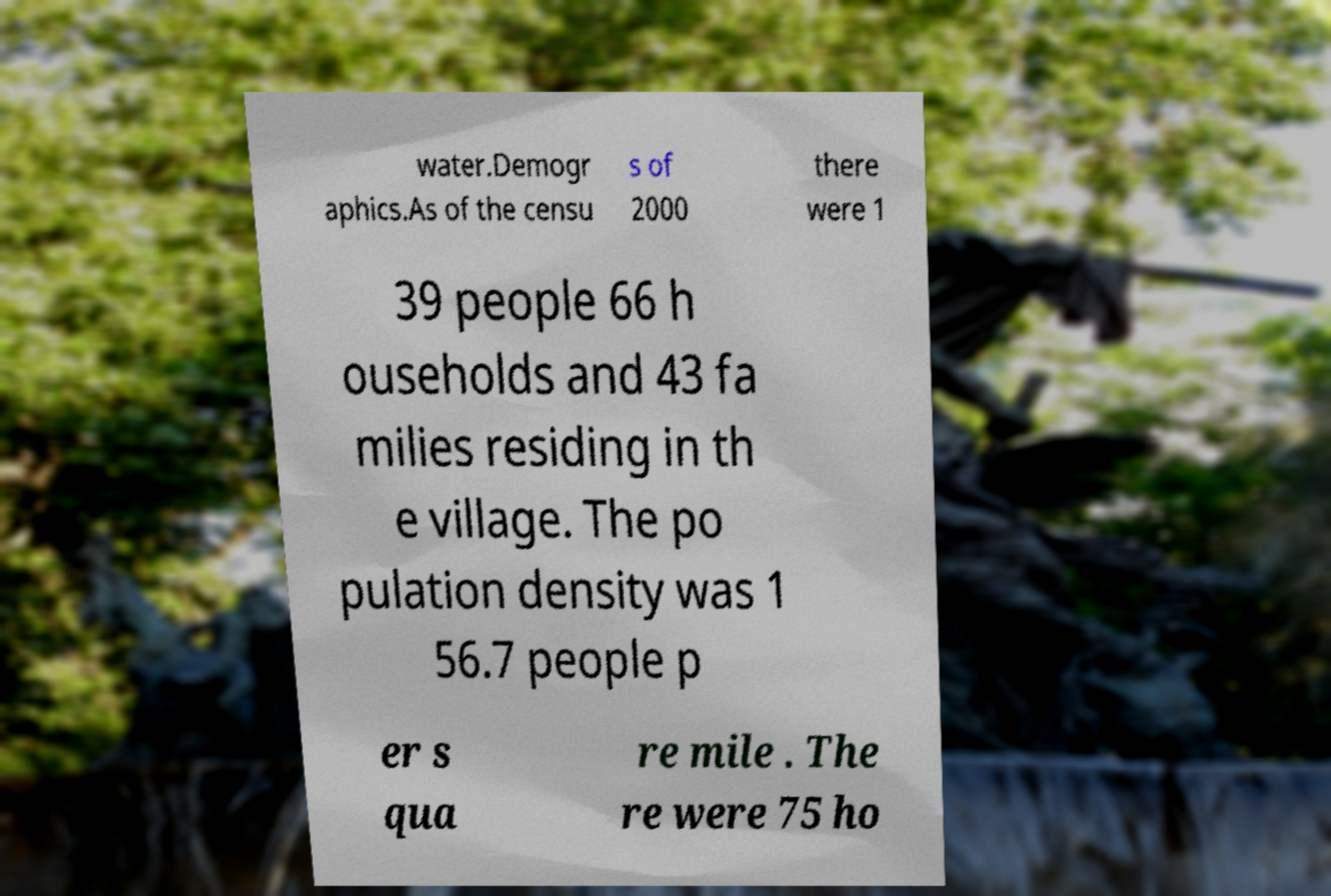What messages or text are displayed in this image? I need them in a readable, typed format. water.Demogr aphics.As of the censu s of 2000 there were 1 39 people 66 h ouseholds and 43 fa milies residing in th e village. The po pulation density was 1 56.7 people p er s qua re mile . The re were 75 ho 